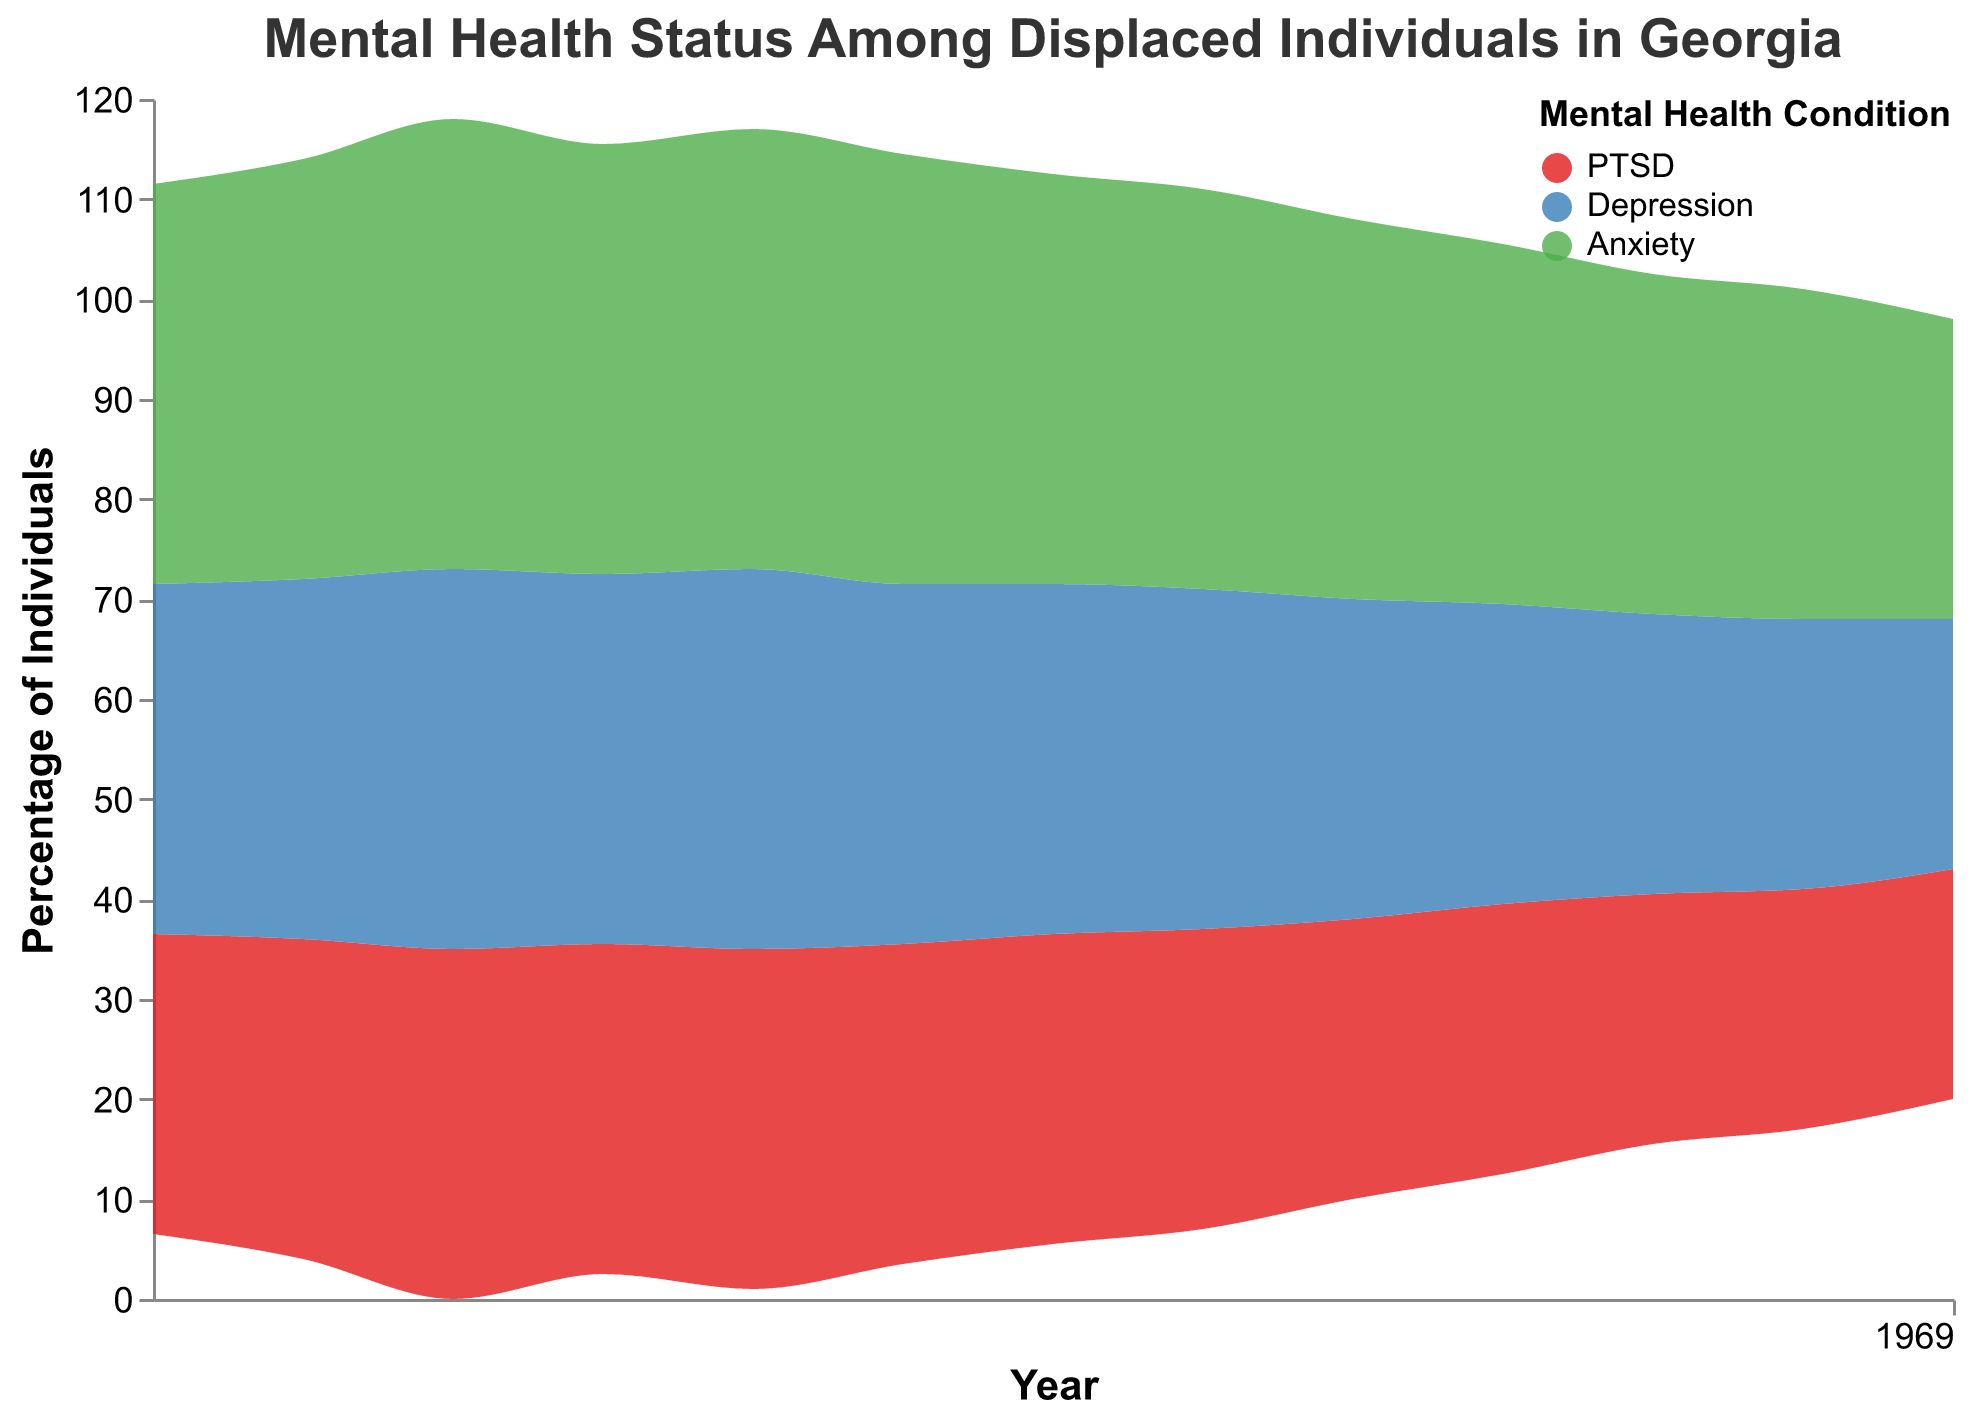What does the title of the figure convey? The title of the figure states "Mental Health Status Among Displaced Individuals in Georgia," which indicates that it presents information on mental health conditions over time for displaced individuals in Georgia.
Answer: Mental Health Status Among Displaced Individuals in Georgia What years does the data cover in the figure? The x-axis of the figure indicates the range of years which the data covers. Observing the x-axis, the figure includes data from the year 2010 to 2022.
Answer: 2010 to 2022 How many mental health conditions are tracked in the figure? The legend of the figure shows three different mental health conditions tracked, indicated by different colors: PTSD, Depression, and Anxiety.
Answer: Three Which mental health condition had the highest percentage in 2012? Observing the highest point on the graph for the year 2012, the green area representing Anxiety is on top, indicating it had the highest percentage.
Answer: Anxiety In what year did the percentage of PTSD peak according to the figure? By observing the red area of the Stream graph, the peak percentage for PTSD occurs in the year 2012.
Answer: 2012 Compare the trend of Depression and Anxiety from 2010 to 2022. Observing the blue and green areas from 2010 to 2022, both Depression and Anxiety show a generally declining trend, but Anxiety starts higher and ends at a lower percentage in 2022 compared to Depression.
Answer: Both declined, Anxiety started higher and ended lower than Depression What is the percentage difference for Anxiety between 2010 and 2022? In 2010, the Anxiety percentage was 40, and in 2022, it was 30. The percentage difference is calculated as 40 - 30 = 10.
Answer: 10 How does the percentage of Depression in 2014 compare to 2020? Checking the figure, in 2014, Depression has a percentage of 38, while in 2020 it has a percentage of 28.
Answer: 38 in 2014; 28 in 2020 Which condition shows the most significant decrease from the year 2010 to 2022? By evaluating the change in the areas, Anxiety shows the most significant decrease, dropping from 40% in 2010 to 30% in 2022, a total of 10 percentage points.
Answer: Anxiety What was the percentage of individuals with PTSD at its lowest point in the observed years? Referencing the red area over the years, the lowest point for PTSD occurred in 2022 at a percentage of 23%.
Answer: 23% in 2022 